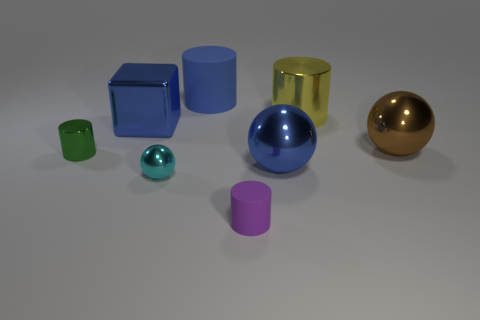Which objects in the image could fit inside each other? The small green cylinder could fit inside the large yellow cylinder, and the small pink cylinder might fit inside the blue cube if the cube were hollow. 